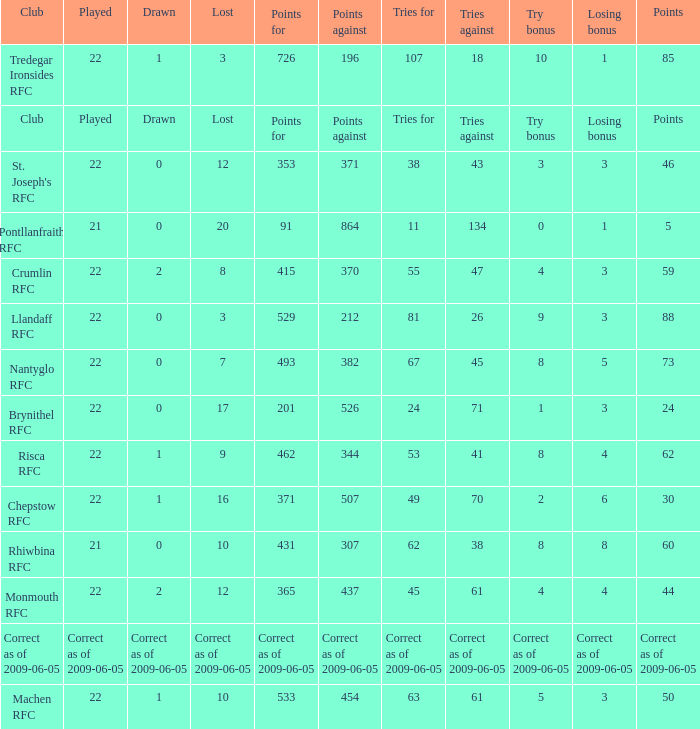If points against was 371, what is the drawn? 0.0. I'm looking to parse the entire table for insights. Could you assist me with that? {'header': ['Club', 'Played', 'Drawn', 'Lost', 'Points for', 'Points against', 'Tries for', 'Tries against', 'Try bonus', 'Losing bonus', 'Points'], 'rows': [['Tredegar Ironsides RFC', '22', '1', '3', '726', '196', '107', '18', '10', '1', '85'], ['Club', 'Played', 'Drawn', 'Lost', 'Points for', 'Points against', 'Tries for', 'Tries against', 'Try bonus', 'Losing bonus', 'Points'], ["St. Joseph's RFC", '22', '0', '12', '353', '371', '38', '43', '3', '3', '46'], ['Pontllanfraith RFC', '21', '0', '20', '91', '864', '11', '134', '0', '1', '5'], ['Crumlin RFC', '22', '2', '8', '415', '370', '55', '47', '4', '3', '59'], ['Llandaff RFC', '22', '0', '3', '529', '212', '81', '26', '9', '3', '88'], ['Nantyglo RFC', '22', '0', '7', '493', '382', '67', '45', '8', '5', '73'], ['Brynithel RFC', '22', '0', '17', '201', '526', '24', '71', '1', '3', '24'], ['Risca RFC', '22', '1', '9', '462', '344', '53', '41', '8', '4', '62'], ['Chepstow RFC', '22', '1', '16', '371', '507', '49', '70', '2', '6', '30'], ['Rhiwbina RFC', '21', '0', '10', '431', '307', '62', '38', '8', '8', '60'], ['Monmouth RFC', '22', '2', '12', '365', '437', '45', '61', '4', '4', '44'], ['Correct as of 2009-06-05', 'Correct as of 2009-06-05', 'Correct as of 2009-06-05', 'Correct as of 2009-06-05', 'Correct as of 2009-06-05', 'Correct as of 2009-06-05', 'Correct as of 2009-06-05', 'Correct as of 2009-06-05', 'Correct as of 2009-06-05', 'Correct as of 2009-06-05', 'Correct as of 2009-06-05'], ['Machen RFC', '22', '1', '10', '533', '454', '63', '61', '5', '3', '50']]} 